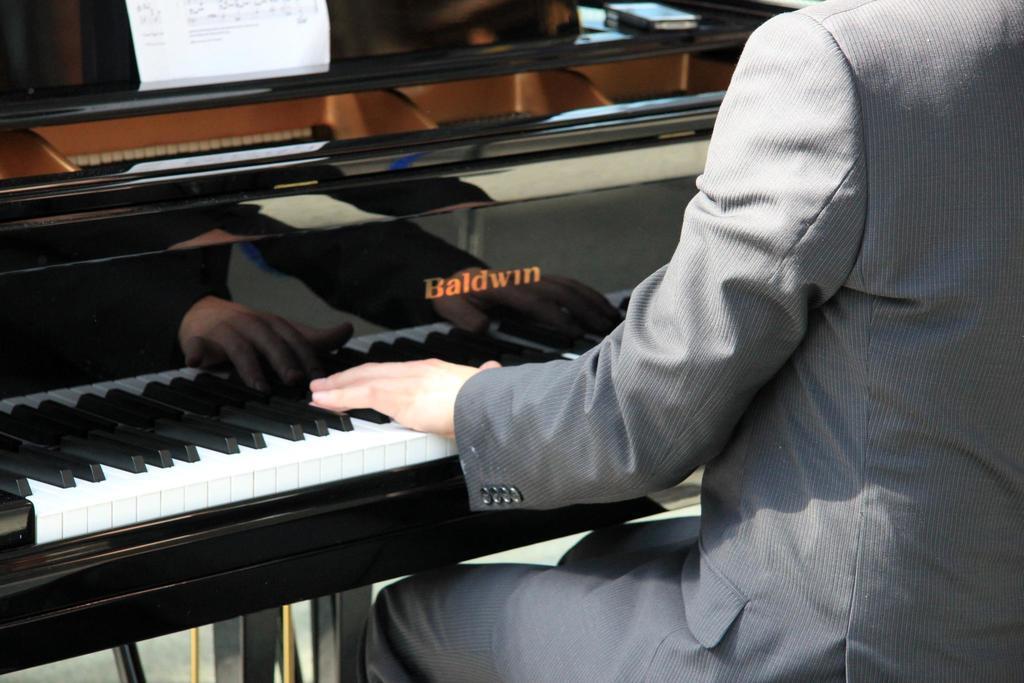Please provide a concise description of this image. This picture is of inside. On the right there is a person wearing suit, sitting and playing piano. On the left there is a paper and a mobile phone placed on the top of the piano table. 